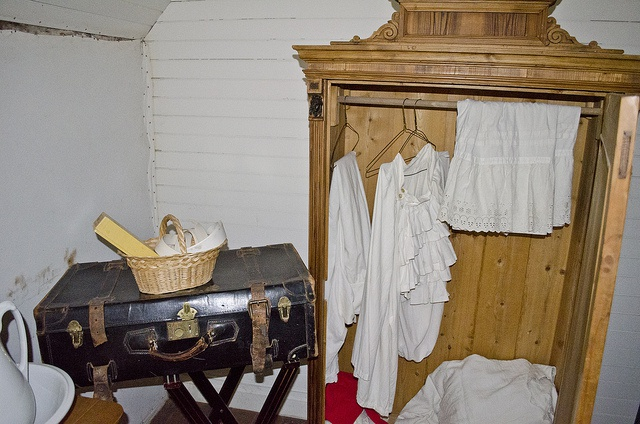Describe the objects in this image and their specific colors. I can see suitcase in gray and black tones and bowl in gray, darkgray, and black tones in this image. 